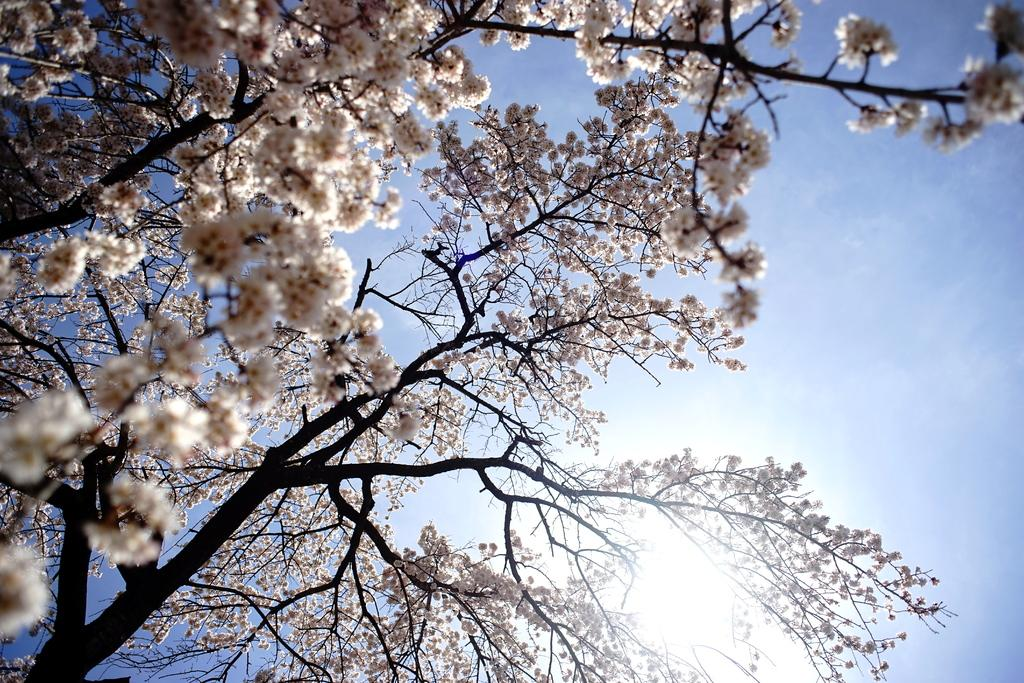What type of vegetation is present in the image? There are branches of a tree in the image. What can be seen on the tree branches? There are white-colored flowers on the tree branches. What is visible in the background of the image? The sun and the sky are visible in the background of the image. What type of comfort can be seen on the tail in the image? There is no mention of a tail or comfort in the image; it features tree branches with white flowers and a background with the sun and sky. 